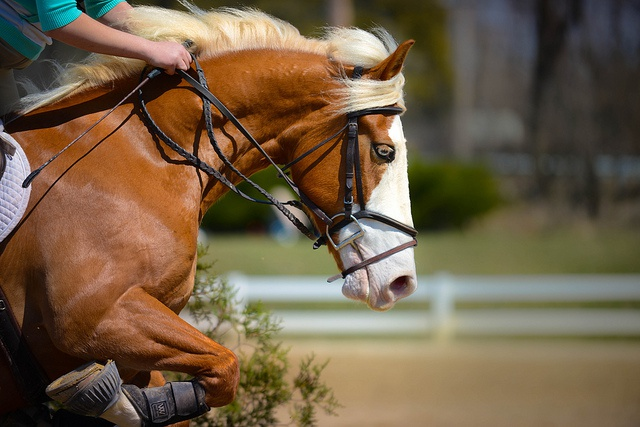Describe the objects in this image and their specific colors. I can see horse in navy, brown, black, and maroon tones and people in navy, black, lightpink, maroon, and lavender tones in this image. 